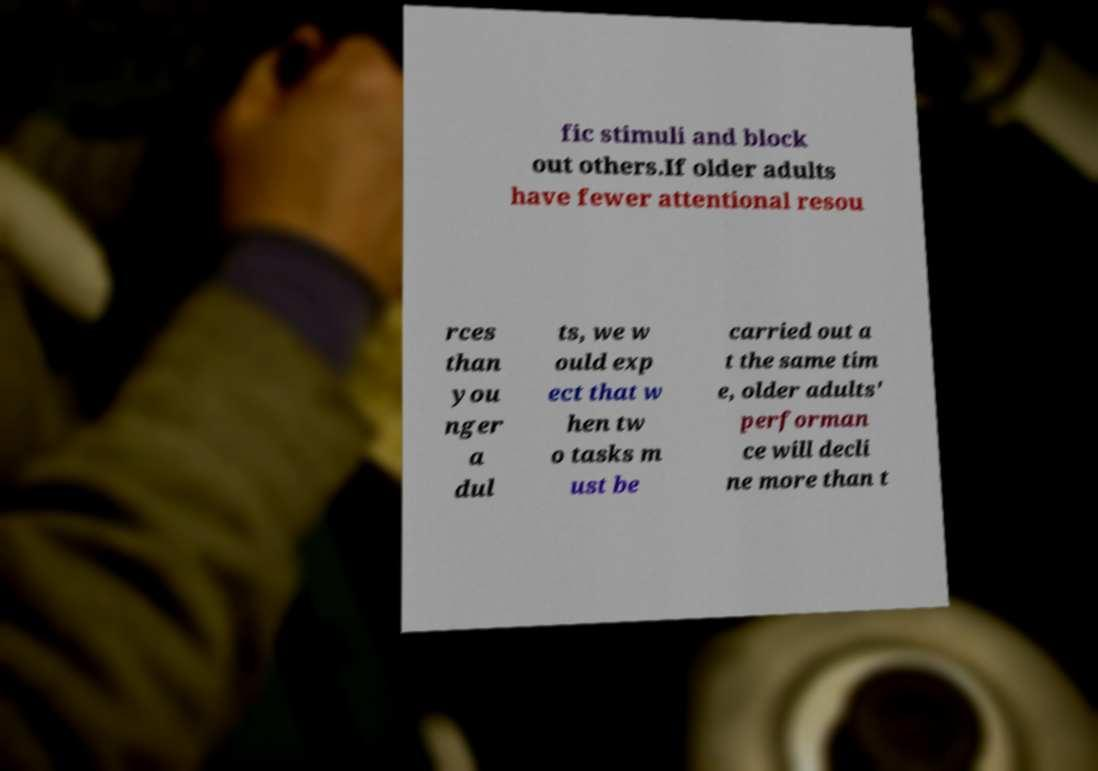Could you extract and type out the text from this image? fic stimuli and block out others.If older adults have fewer attentional resou rces than you nger a dul ts, we w ould exp ect that w hen tw o tasks m ust be carried out a t the same tim e, older adults' performan ce will decli ne more than t 